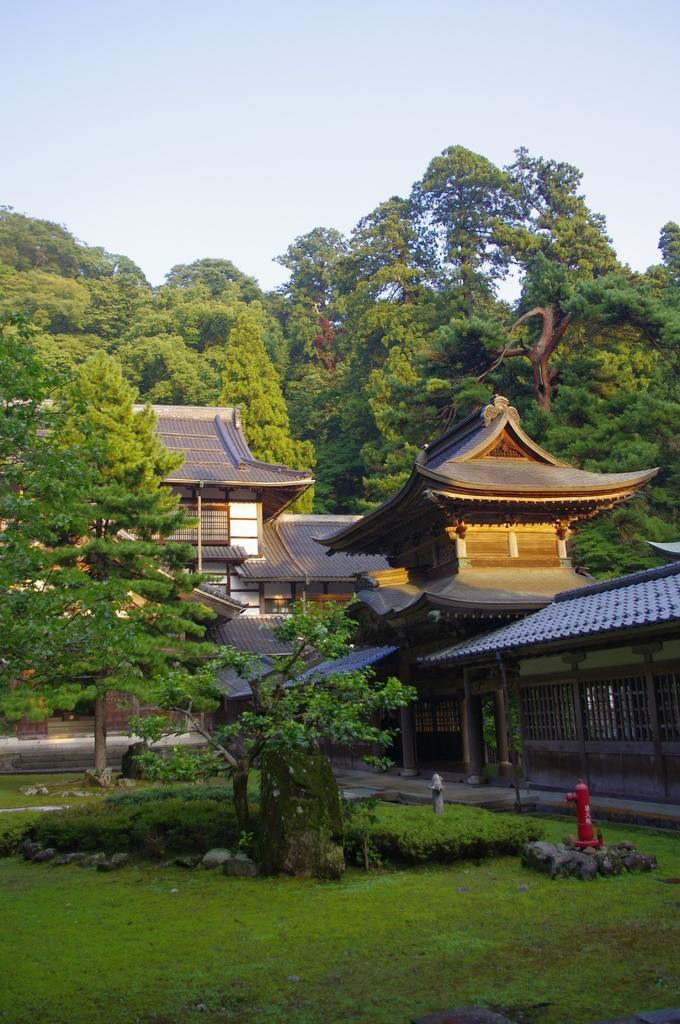Can you describe this image briefly? This is an outside view. At the bottom, I can see the grass on the ground. In the middle of the image there is a building. In the background there are many trees. At the top of the image I can see the sky. 